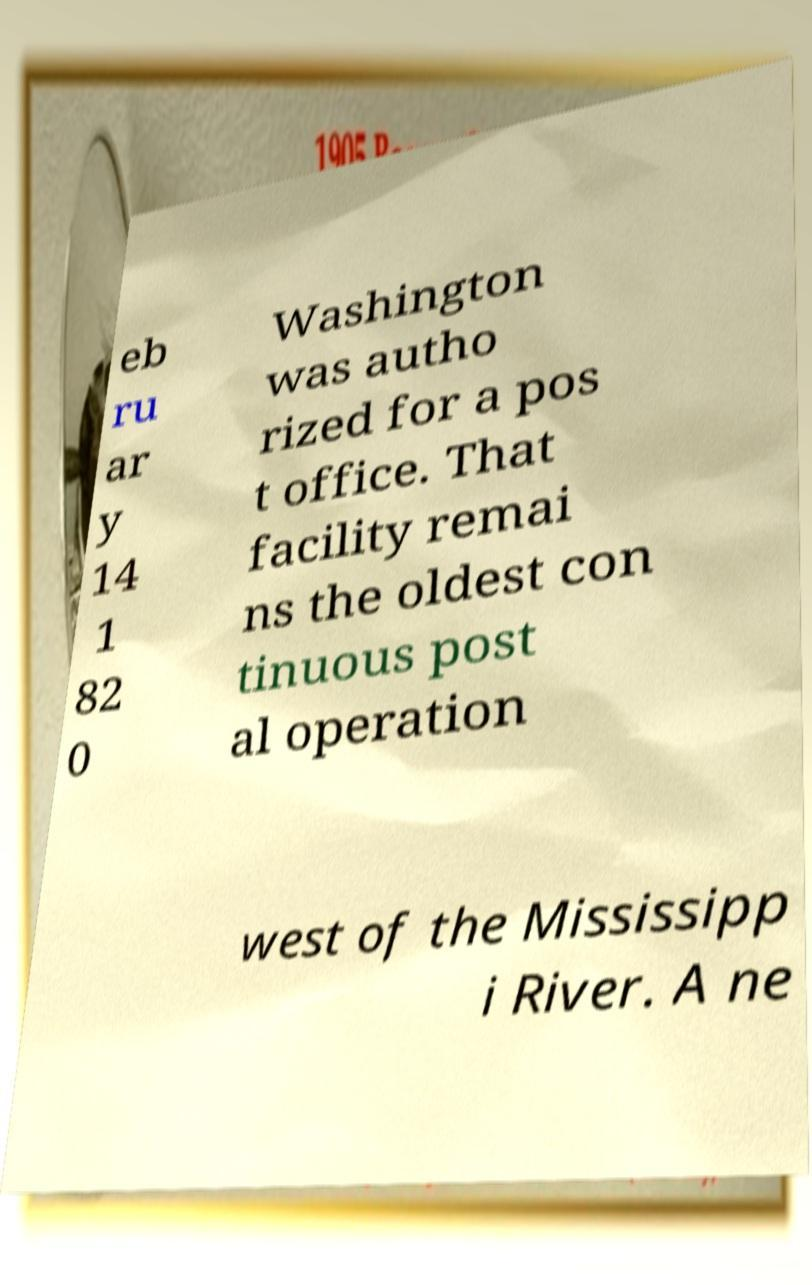There's text embedded in this image that I need extracted. Can you transcribe it verbatim? eb ru ar y 14 1 82 0 Washington was autho rized for a pos t office. That facility remai ns the oldest con tinuous post al operation west of the Mississipp i River. A ne 